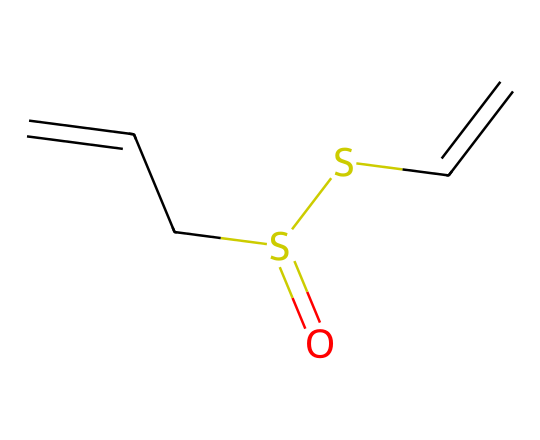What is the total number of carbon atoms in allicin? By examining the SMILES representation O=S(CC=C)SC=C, I can count the carbon atoms. There are four carbon atoms in the molecule indicated by “CC=C”, which represents a carbon-carbon double bond structure and the “C” before the double bond. So, the total number of carbon atoms is four.
Answer: four How many sulfur atoms are present in allicin? In the SMILES structure O=S(CC=C)SC=C, I can see the "S" characters. There are two "S" which represent the sulfur atoms. Thus, allicin consists of two sulfur atoms.
Answer: two What functional groups are identified in the structure of allicin? The SMILES shows the presence of a sulfoxide functional group (due to "O=S" indicating sulfur bonded to oxygen) and thioether (observed by the connecting sulfur atoms "S" in a chain). Therefore, allicin features these functional groups.
Answer: sulfoxide and thioether What type of bond is primarily found between the carbon atoms in allicin? By looking at the “CC=C” part of the SMILES, I can see that there is a double bond between the third and fourth carbon atoms indicated by the “=”. This indicates that the primary bond type between the carbon atoms is a double bond.
Answer: double bond What unique smell characteristic is related to allicin? Allicin is known for its strong aroma, which is typically described as garlicky due to the presence of sulfur. The structure with the sulfur atoms contributes heavily to this distinct smell. Thus, it can be classified under organosulfur compounds known for their characteristic odors.
Answer: garlicky 